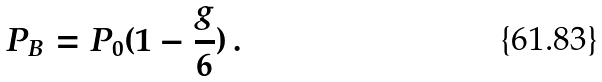Convert formula to latex. <formula><loc_0><loc_0><loc_500><loc_500>P _ { B } = P _ { 0 } ( 1 - \frac { g } { 6 } ) \, .</formula> 